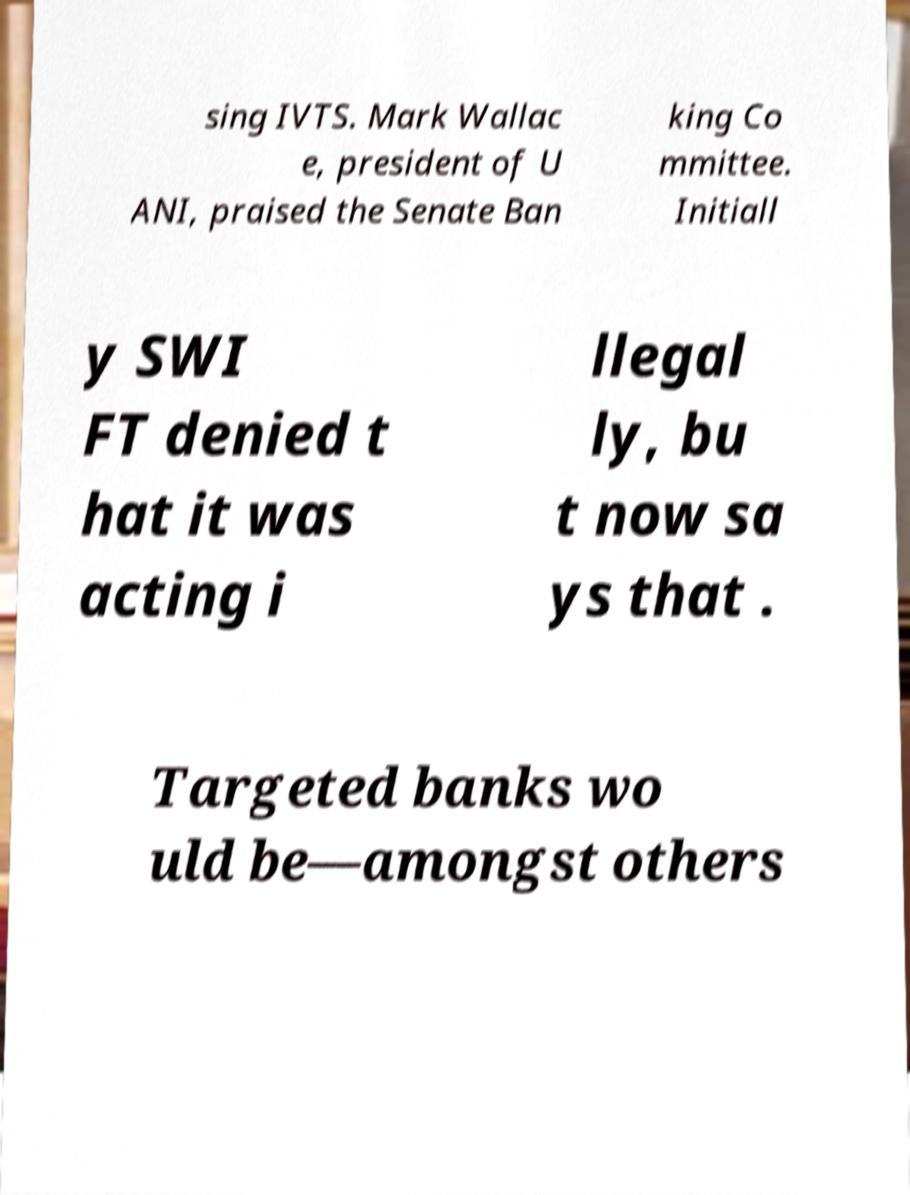For documentation purposes, I need the text within this image transcribed. Could you provide that? sing IVTS. Mark Wallac e, president of U ANI, praised the Senate Ban king Co mmittee. Initiall y SWI FT denied t hat it was acting i llegal ly, bu t now sa ys that . Targeted banks wo uld be—amongst others 